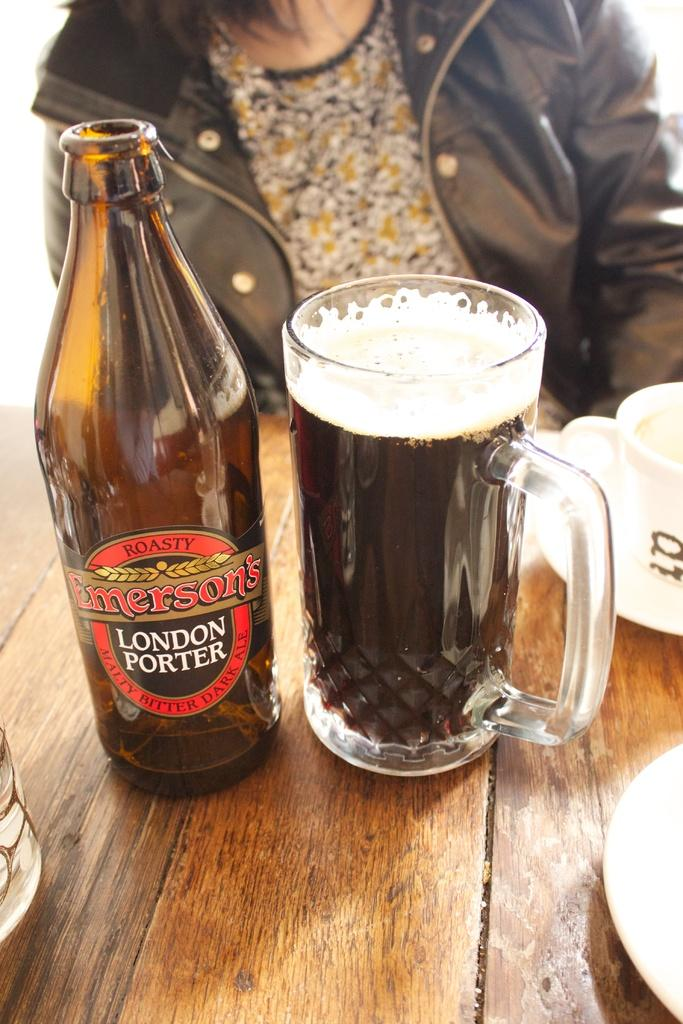<image>
Give a short and clear explanation of the subsequent image. A mug containing a dark bitter ale called London Porter by Emerson's 